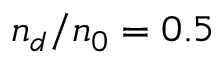<formula> <loc_0><loc_0><loc_500><loc_500>n _ { d } / n _ { 0 } = 0 . 5</formula> 